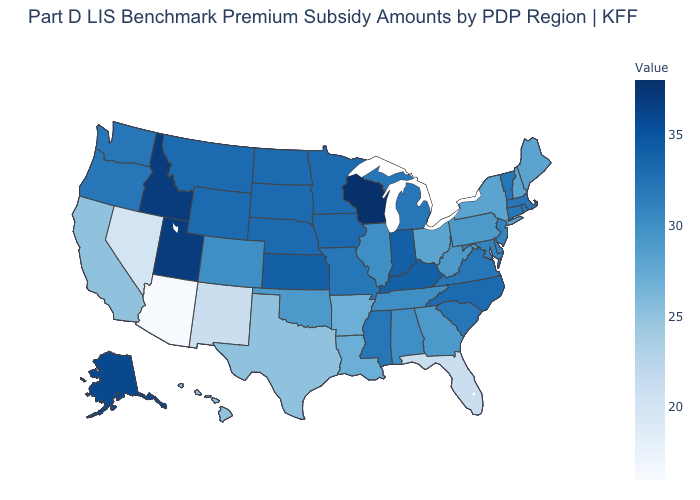Does Arizona have the lowest value in the West?
Keep it brief. Yes. Does Wisconsin have the highest value in the USA?
Write a very short answer. Yes. Among the states that border Idaho , which have the lowest value?
Quick response, please. Nevada. Which states hav the highest value in the MidWest?
Be succinct. Wisconsin. Does the map have missing data?
Give a very brief answer. No. Among the states that border North Carolina , which have the highest value?
Quick response, please. South Carolina, Virginia. Does Wisconsin have the highest value in the USA?
Be succinct. Yes. Among the states that border Nevada , which have the highest value?
Write a very short answer. Idaho, Utah. 